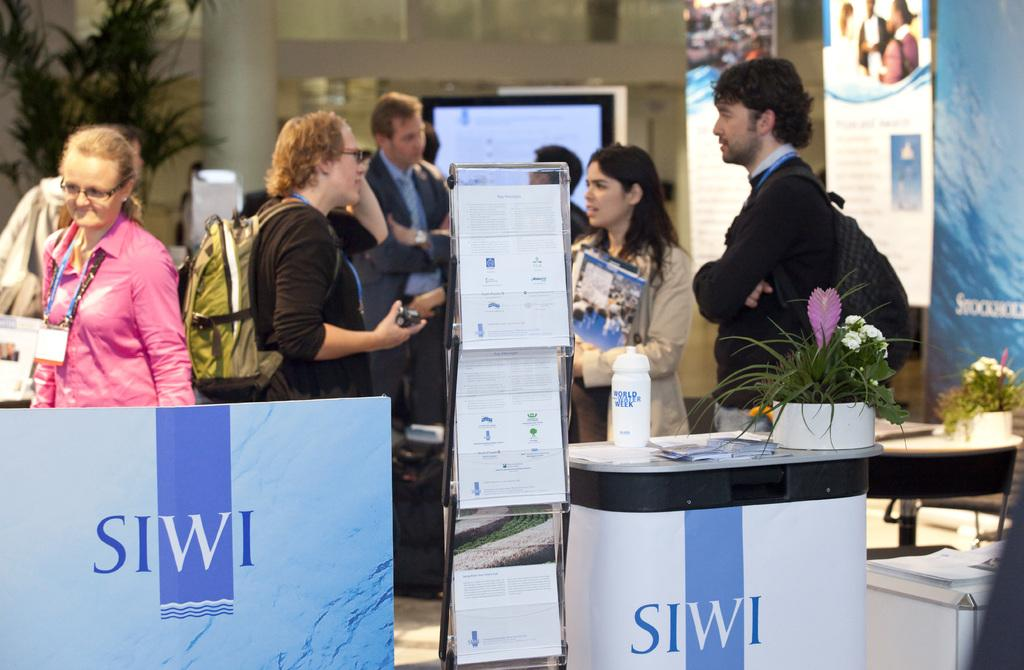<image>
Relay a brief, clear account of the picture shown. many people are gathered around a table labeled SIWI at a convention 